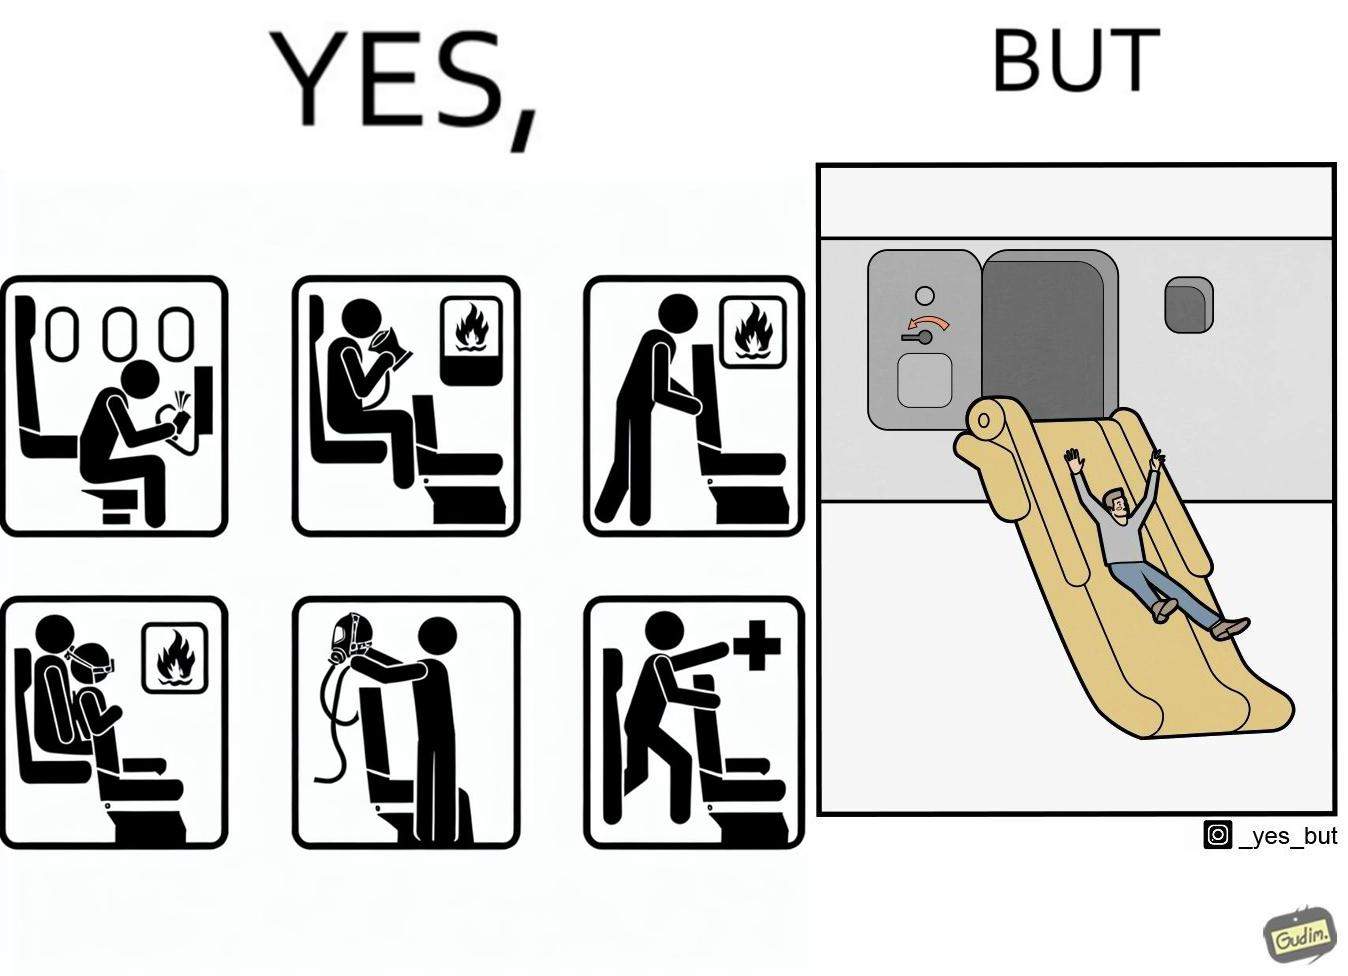Describe the satirical element in this image. These images are funny since it shows how we are taught emergency procedures to follow in case of an accident while in an airplane but how none of them work if the plane is still in air 